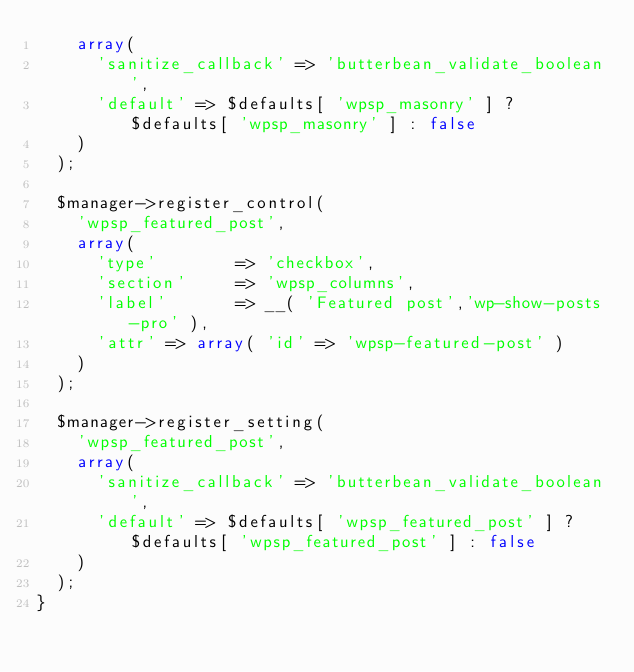Convert code to text. <code><loc_0><loc_0><loc_500><loc_500><_PHP_>		array(
			'sanitize_callback' => 'butterbean_validate_boolean',
			'default' => $defaults[ 'wpsp_masonry' ] ? $defaults[ 'wpsp_masonry' ] : false
		)
	);

	$manager->register_control(
		'wpsp_featured_post',
		array(
			'type'        => 'checkbox',
			'section'     => 'wpsp_columns',
			'label'       => __( 'Featured post','wp-show-posts-pro' ),
			'attr' => array( 'id' => 'wpsp-featured-post' )
		)
	);

	$manager->register_setting(
		'wpsp_featured_post',
		array(
			'sanitize_callback' => 'butterbean_validate_boolean',
			'default' => $defaults[ 'wpsp_featured_post' ] ? $defaults[ 'wpsp_featured_post' ] : false
		)
	);
}</code> 